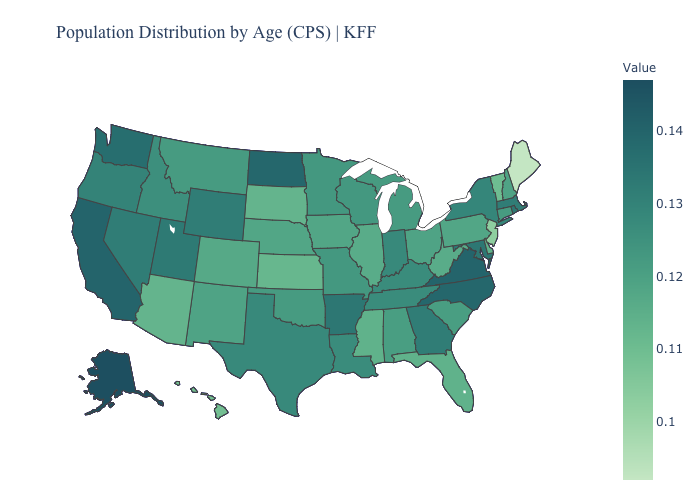Which states have the highest value in the USA?
Quick response, please. Alaska. Among the states that border Arizona , which have the highest value?
Answer briefly. California. Does North Dakota have the highest value in the MidWest?
Be succinct. Yes. Does South Carolina have the lowest value in the South?
Write a very short answer. No. Among the states that border Wisconsin , does Minnesota have the highest value?
Quick response, please. Yes. Which states hav the highest value in the West?
Be succinct. Alaska. 